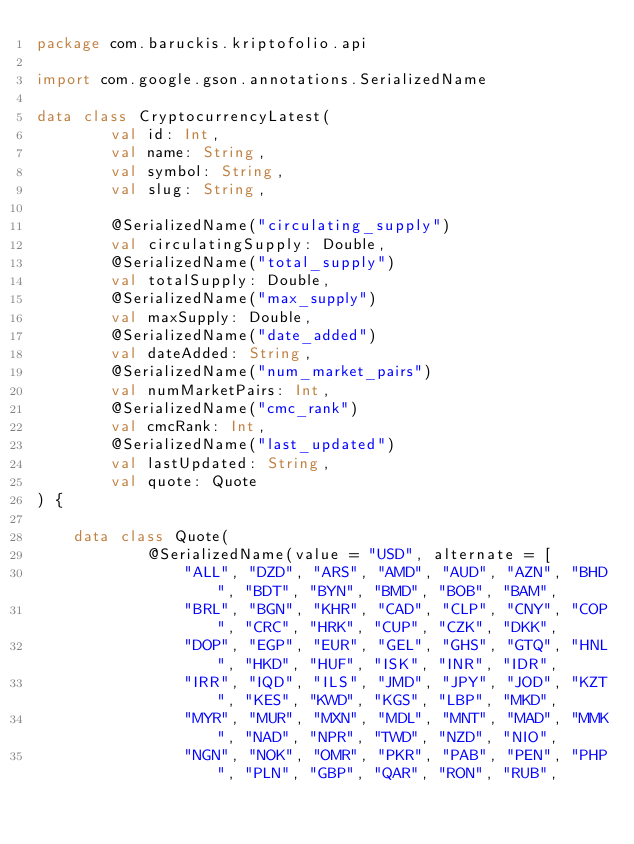Convert code to text. <code><loc_0><loc_0><loc_500><loc_500><_Kotlin_>package com.baruckis.kriptofolio.api

import com.google.gson.annotations.SerializedName

data class CryptocurrencyLatest(
        val id: Int,
        val name: String,
        val symbol: String,
        val slug: String,

        @SerializedName("circulating_supply")
        val circulatingSupply: Double,
        @SerializedName("total_supply")
        val totalSupply: Double,
        @SerializedName("max_supply")
        val maxSupply: Double,
        @SerializedName("date_added")
        val dateAdded: String,
        @SerializedName("num_market_pairs")
        val numMarketPairs: Int,
        @SerializedName("cmc_rank")
        val cmcRank: Int,
        @SerializedName("last_updated")
        val lastUpdated: String,
        val quote: Quote
) {

    data class Quote(
            @SerializedName(value = "USD", alternate = [
                "ALL", "DZD", "ARS", "AMD", "AUD", "AZN", "BHD", "BDT", "BYN", "BMD", "BOB", "BAM",
                "BRL", "BGN", "KHR", "CAD", "CLP", "CNY", "COP", "CRC", "HRK", "CUP", "CZK", "DKK",
                "DOP", "EGP", "EUR", "GEL", "GHS", "GTQ", "HNL", "HKD", "HUF", "ISK", "INR", "IDR",
                "IRR", "IQD", "ILS", "JMD", "JPY", "JOD", "KZT", "KES", "KWD", "KGS", "LBP", "MKD",
                "MYR", "MUR", "MXN", "MDL", "MNT", "MAD", "MMK", "NAD", "NPR", "TWD", "NZD", "NIO",
                "NGN", "NOK", "OMR", "PKR", "PAB", "PEN", "PHP", "PLN", "GBP", "QAR", "RON", "RUB",</code> 